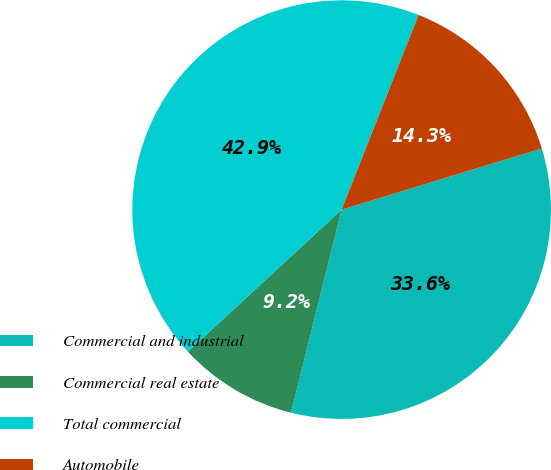Convert chart. <chart><loc_0><loc_0><loc_500><loc_500><pie_chart><fcel>Commercial and industrial<fcel>Commercial real estate<fcel>Total commercial<fcel>Automobile<nl><fcel>33.61%<fcel>9.24%<fcel>42.86%<fcel>14.29%<nl></chart> 